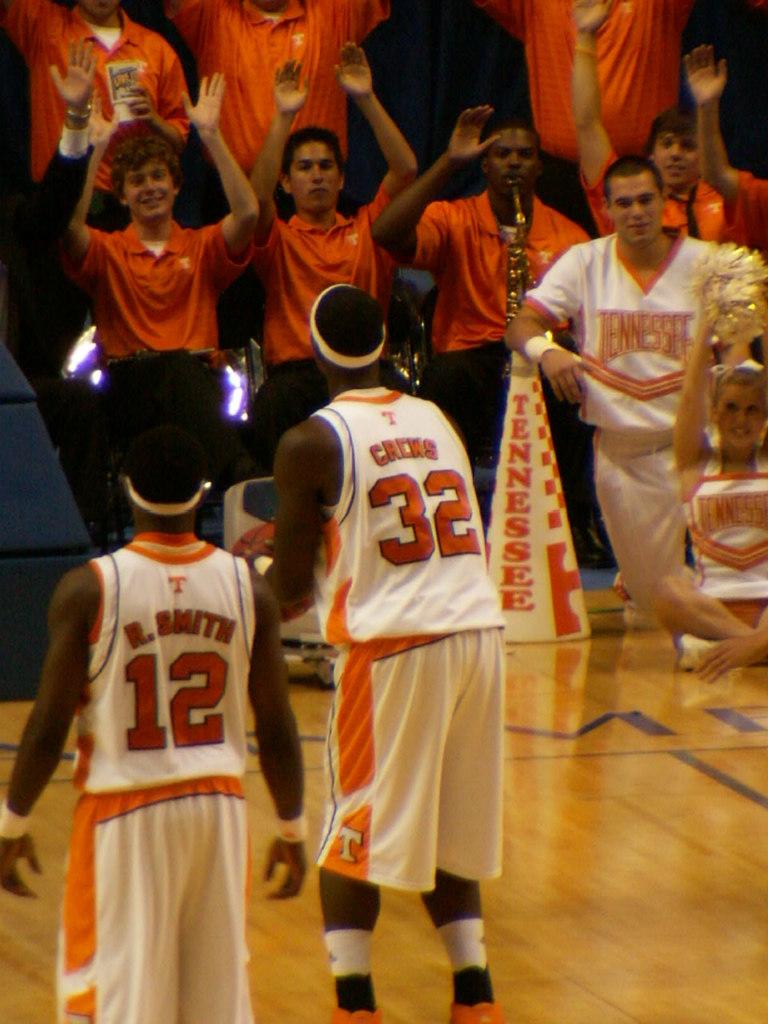What players are on the court?
Offer a terse response. 12 32. What state is on the cone?
Your answer should be very brief. Tennessee. 